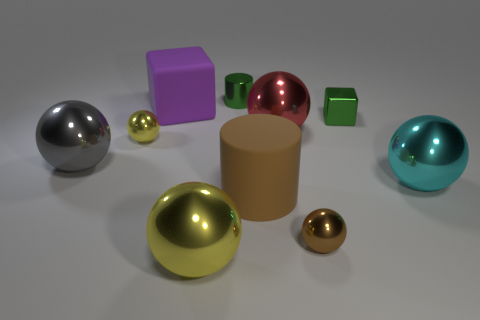Subtract all tiny metallic spheres. How many spheres are left? 4 Subtract all green blocks. How many blocks are left? 1 Add 9 large cylinders. How many large cylinders exist? 10 Subtract 1 purple blocks. How many objects are left? 9 Subtract all cubes. How many objects are left? 8 Subtract 1 cylinders. How many cylinders are left? 1 Subtract all yellow cylinders. Subtract all brown blocks. How many cylinders are left? 2 Subtract all blue blocks. How many gray spheres are left? 1 Subtract all big yellow spheres. Subtract all big matte cylinders. How many objects are left? 8 Add 9 small cylinders. How many small cylinders are left? 10 